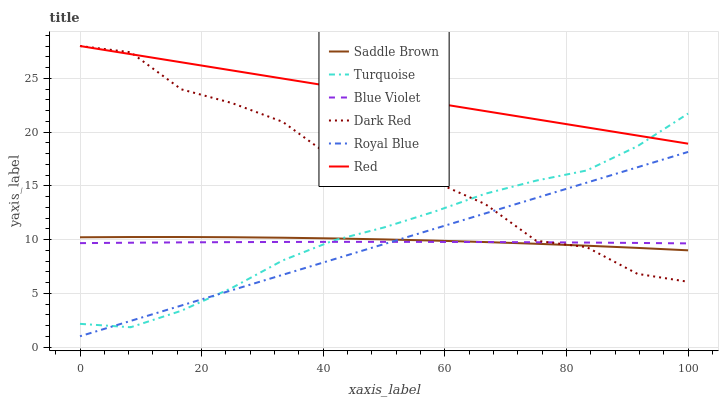Does Royal Blue have the minimum area under the curve?
Answer yes or no. Yes. Does Red have the maximum area under the curve?
Answer yes or no. Yes. Does Dark Red have the minimum area under the curve?
Answer yes or no. No. Does Dark Red have the maximum area under the curve?
Answer yes or no. No. Is Red the smoothest?
Answer yes or no. Yes. Is Dark Red the roughest?
Answer yes or no. Yes. Is Royal Blue the smoothest?
Answer yes or no. No. Is Royal Blue the roughest?
Answer yes or no. No. Does Royal Blue have the lowest value?
Answer yes or no. Yes. Does Dark Red have the lowest value?
Answer yes or no. No. Does Red have the highest value?
Answer yes or no. Yes. Does Royal Blue have the highest value?
Answer yes or no. No. Is Saddle Brown less than Red?
Answer yes or no. Yes. Is Red greater than Saddle Brown?
Answer yes or no. Yes. Does Royal Blue intersect Saddle Brown?
Answer yes or no. Yes. Is Royal Blue less than Saddle Brown?
Answer yes or no. No. Is Royal Blue greater than Saddle Brown?
Answer yes or no. No. Does Saddle Brown intersect Red?
Answer yes or no. No. 